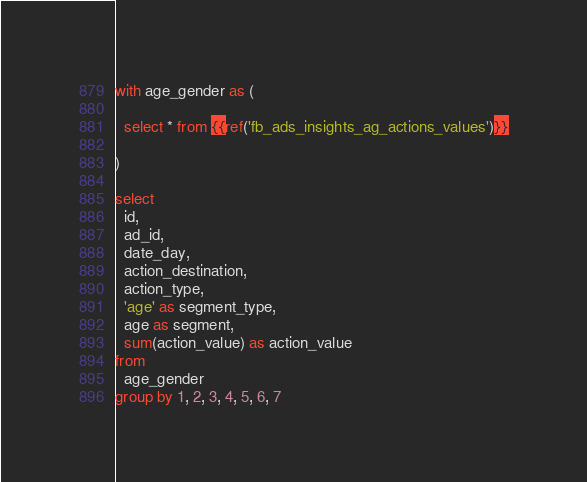<code> <loc_0><loc_0><loc_500><loc_500><_SQL_>with age_gender as (

  select * from {{ref('fb_ads_insights_ag_actions_values')}}

)

select
  id,
  ad_id,
  date_day,
  action_destination,
  action_type,
  'age' as segment_type,
  age as segment,
  sum(action_value) as action_value
from
  age_gender
group by 1, 2, 3, 4, 5, 6, 7
</code> 